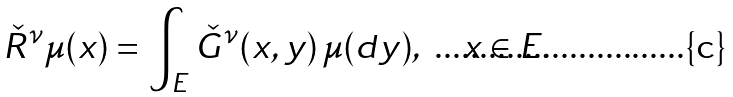<formula> <loc_0><loc_0><loc_500><loc_500>\check { R } ^ { \nu } \mu ( x ) = \int _ { E } \check { G } ^ { \nu } ( x , y ) \, \mu ( d y ) , \quad x \in E .</formula> 